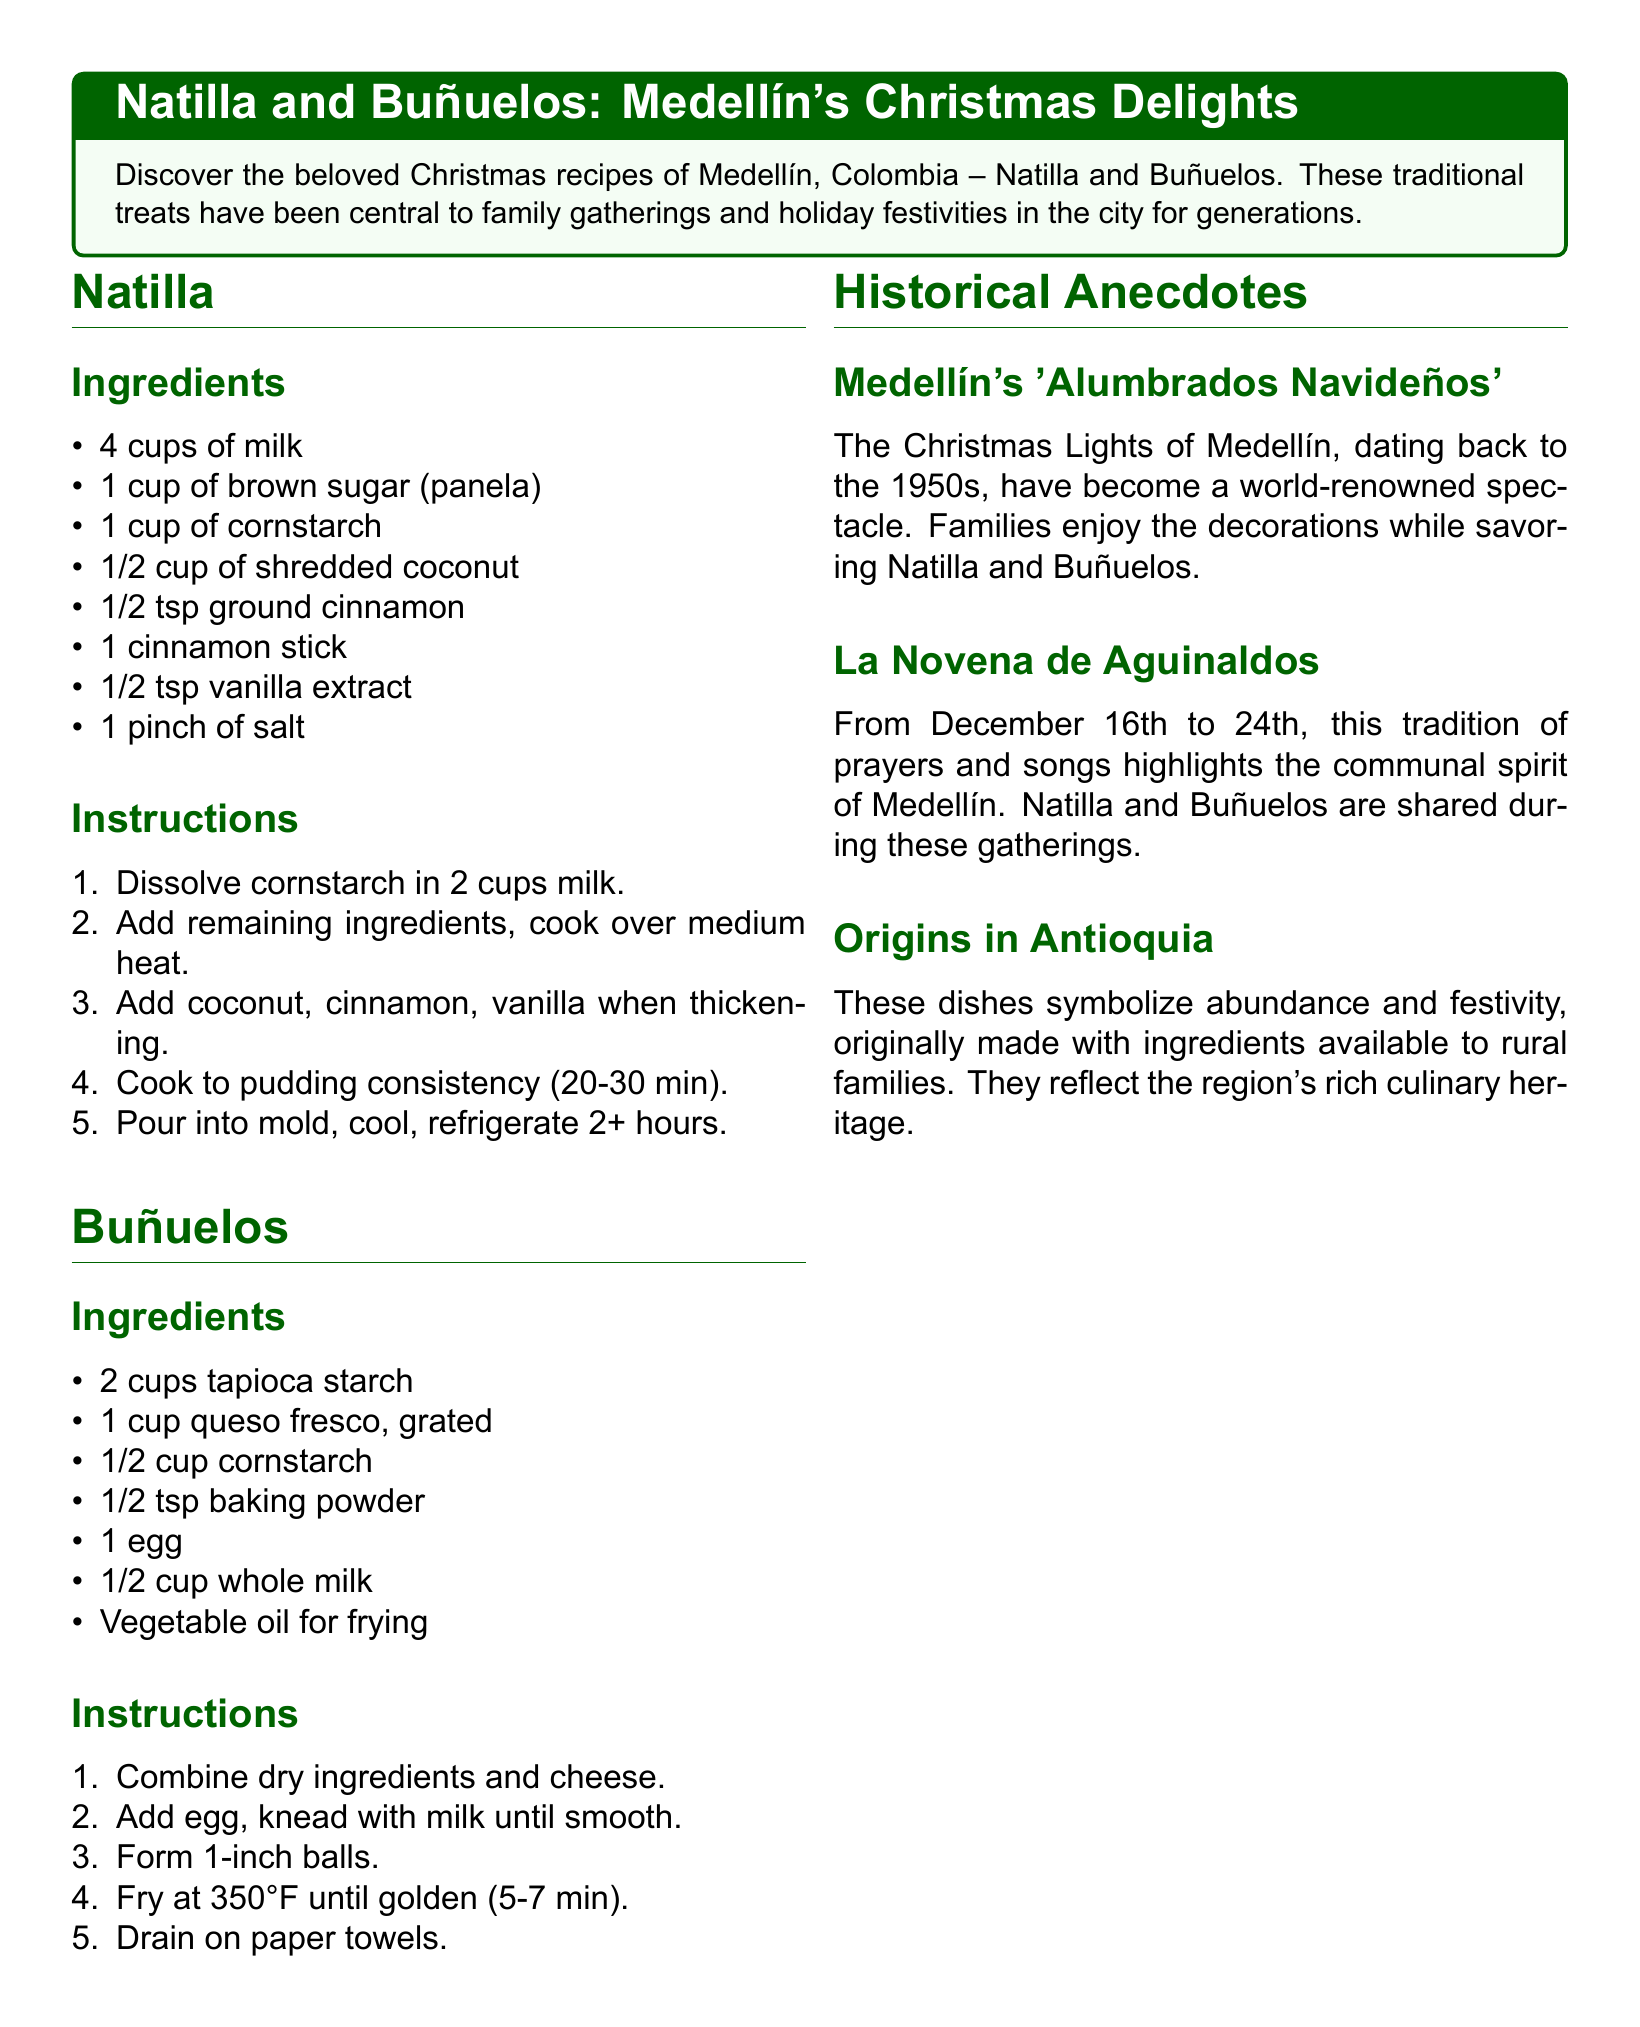What are the main ingredients for Natilla? The main ingredients listed for Natilla are milk, brown sugar, cornstarch, shredded coconut, ground cinnamon, cinnamon stick, vanilla extract, and salt.
Answer: milk, brown sugar, cornstarch, shredded coconut, ground cinnamon, cinnamon stick, vanilla extract, salt How long should Natilla be refrigerated? The document states that Natilla should cool and be refrigerated for 2 or more hours.
Answer: 2+ hours What is the first step in making Buñuelos? The first step in making Buñuelos is to combine the dry ingredients and cheese.
Answer: Combine dry ingredients and cheese What tradition is highlighted from December 16th to 24th? The tradition highlighted is “La Novena de Aguinaldos.”
Answer: La Novena de Aguinaldos In which decade did the Christmas Lights of Medellín begin? The Christmas Lights of Medellín started in the 1950s.
Answer: 1950s What type of cheese is used in Buñuelos? The cheese used in Buñuelos is queso fresco.
Answer: queso fresco Which two traditional treats are central to Medellín's Christmas celebrations? The two traditional treats central to Christmas celebrations in Medellín are Natilla and Buñuelos.
Answer: Natilla and Buñuelos What does Natilla symbolize in terms of cultural heritage? Natilla symbolizes abundance and festivity.
Answer: abundance and festivity 